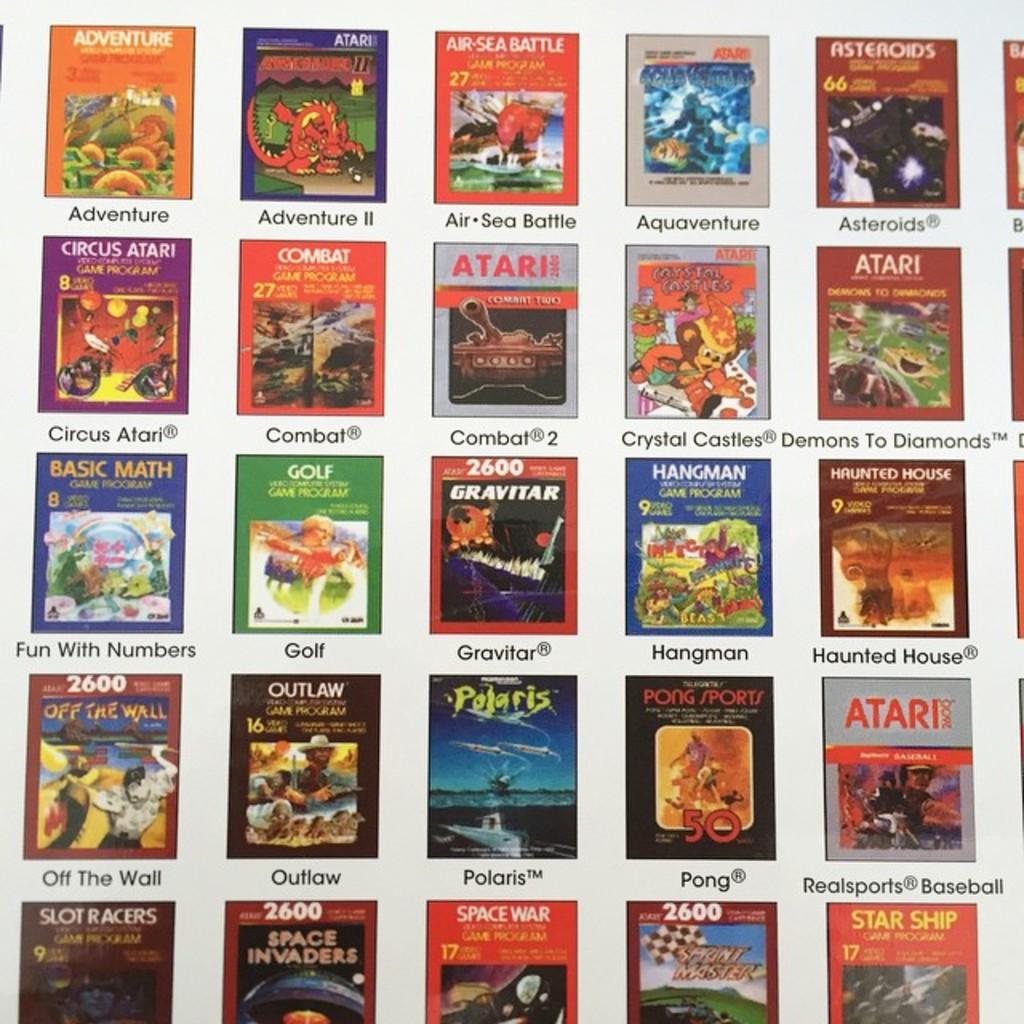What is the name of the game on the top right?
Provide a short and direct response. Asteroids. What are these movies or games?
Your answer should be very brief. Games. 